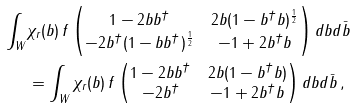<formula> <loc_0><loc_0><loc_500><loc_500>\int _ { W } & \chi _ { r } ( b ) \, f \begin{pmatrix} 1 - 2 b b ^ { \dagger } & 2 b ( 1 - b ^ { \dagger } b ) ^ { \frac { 1 } { 2 } } \\ - 2 b ^ { \dagger } ( 1 - b b ^ { \dagger } ) ^ { \frac { 1 } { 2 } } & - 1 + 2 b ^ { \dagger } b \end{pmatrix} d b d \bar { b } \\ & = \int _ { W } \chi _ { r } ( b ) \, f \begin{pmatrix} 1 - 2 b b ^ { \dagger } & 2 b ( 1 - b ^ { \dagger } b ) \\ - 2 b ^ { \dagger } & - 1 + 2 b ^ { \dagger } b \end{pmatrix} d b d \bar { b } \, ,</formula> 